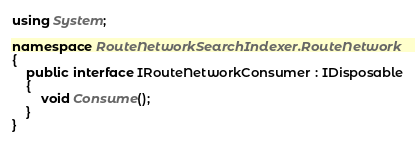<code> <loc_0><loc_0><loc_500><loc_500><_C#_>using System;

namespace RouteNetworkSearchIndexer.RouteNetwork
{
    public interface IRouteNetworkConsumer : IDisposable
    {
        void Consume();
    }
}
</code> 